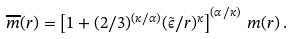Convert formula to latex. <formula><loc_0><loc_0><loc_500><loc_500>\overline { m } ( r ) = \left [ 1 + ( 2 / 3 ) ^ { ( \kappa / \alpha ) } ( \tilde { \epsilon } / r ) ^ { \kappa } \right ] ^ { ( \alpha / \kappa ) } \, m ( r ) \, .</formula> 